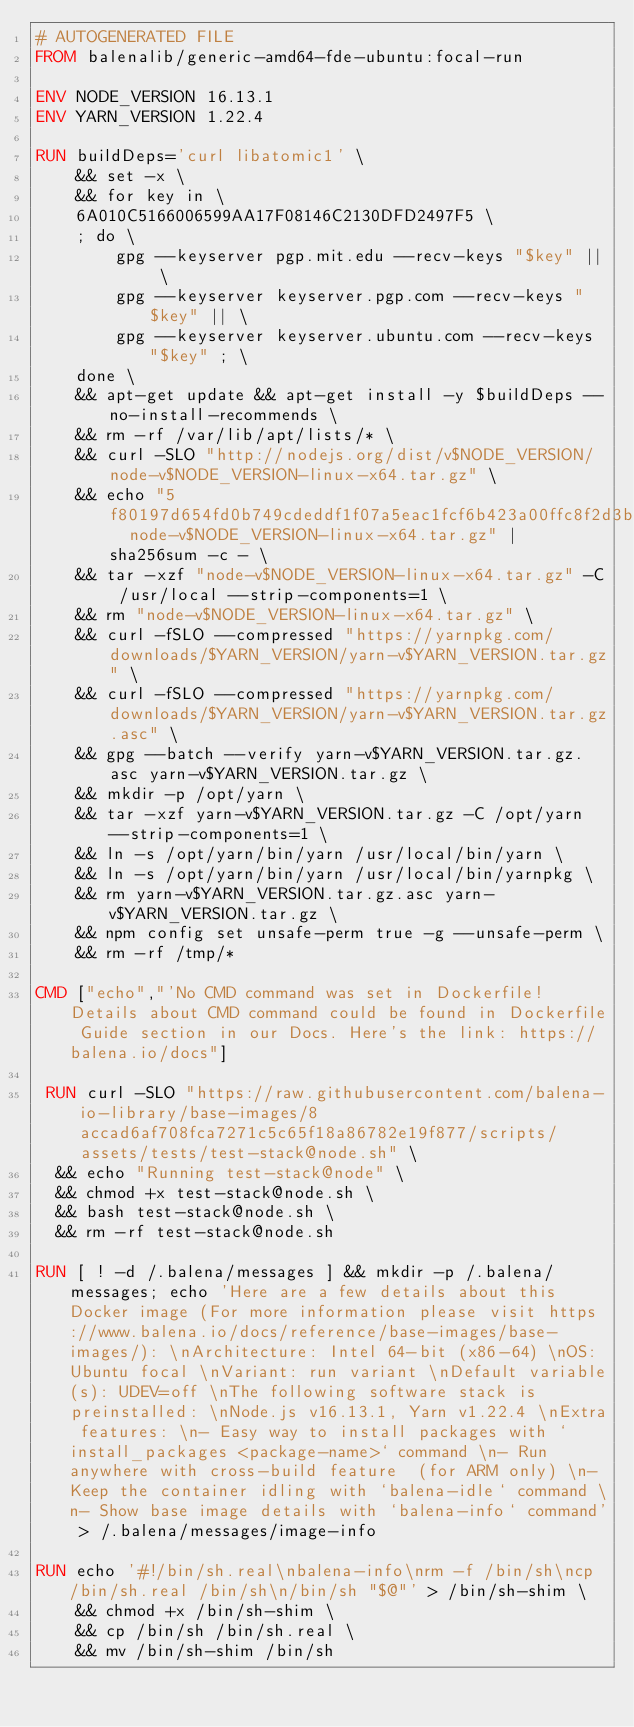<code> <loc_0><loc_0><loc_500><loc_500><_Dockerfile_># AUTOGENERATED FILE
FROM balenalib/generic-amd64-fde-ubuntu:focal-run

ENV NODE_VERSION 16.13.1
ENV YARN_VERSION 1.22.4

RUN buildDeps='curl libatomic1' \
	&& set -x \
	&& for key in \
	6A010C5166006599AA17F08146C2130DFD2497F5 \
	; do \
		gpg --keyserver pgp.mit.edu --recv-keys "$key" || \
		gpg --keyserver keyserver.pgp.com --recv-keys "$key" || \
		gpg --keyserver keyserver.ubuntu.com --recv-keys "$key" ; \
	done \
	&& apt-get update && apt-get install -y $buildDeps --no-install-recommends \
	&& rm -rf /var/lib/apt/lists/* \
	&& curl -SLO "http://nodejs.org/dist/v$NODE_VERSION/node-v$NODE_VERSION-linux-x64.tar.gz" \
	&& echo "5f80197d654fd0b749cdeddf1f07a5eac1fcf6b423a00ffc8f2d3bea9c6dc8d1  node-v$NODE_VERSION-linux-x64.tar.gz" | sha256sum -c - \
	&& tar -xzf "node-v$NODE_VERSION-linux-x64.tar.gz" -C /usr/local --strip-components=1 \
	&& rm "node-v$NODE_VERSION-linux-x64.tar.gz" \
	&& curl -fSLO --compressed "https://yarnpkg.com/downloads/$YARN_VERSION/yarn-v$YARN_VERSION.tar.gz" \
	&& curl -fSLO --compressed "https://yarnpkg.com/downloads/$YARN_VERSION/yarn-v$YARN_VERSION.tar.gz.asc" \
	&& gpg --batch --verify yarn-v$YARN_VERSION.tar.gz.asc yarn-v$YARN_VERSION.tar.gz \
	&& mkdir -p /opt/yarn \
	&& tar -xzf yarn-v$YARN_VERSION.tar.gz -C /opt/yarn --strip-components=1 \
	&& ln -s /opt/yarn/bin/yarn /usr/local/bin/yarn \
	&& ln -s /opt/yarn/bin/yarn /usr/local/bin/yarnpkg \
	&& rm yarn-v$YARN_VERSION.tar.gz.asc yarn-v$YARN_VERSION.tar.gz \
	&& npm config set unsafe-perm true -g --unsafe-perm \
	&& rm -rf /tmp/*

CMD ["echo","'No CMD command was set in Dockerfile! Details about CMD command could be found in Dockerfile Guide section in our Docs. Here's the link: https://balena.io/docs"]

 RUN curl -SLO "https://raw.githubusercontent.com/balena-io-library/base-images/8accad6af708fca7271c5c65f18a86782e19f877/scripts/assets/tests/test-stack@node.sh" \
  && echo "Running test-stack@node" \
  && chmod +x test-stack@node.sh \
  && bash test-stack@node.sh \
  && rm -rf test-stack@node.sh 

RUN [ ! -d /.balena/messages ] && mkdir -p /.balena/messages; echo 'Here are a few details about this Docker image (For more information please visit https://www.balena.io/docs/reference/base-images/base-images/): \nArchitecture: Intel 64-bit (x86-64) \nOS: Ubuntu focal \nVariant: run variant \nDefault variable(s): UDEV=off \nThe following software stack is preinstalled: \nNode.js v16.13.1, Yarn v1.22.4 \nExtra features: \n- Easy way to install packages with `install_packages <package-name>` command \n- Run anywhere with cross-build feature  (for ARM only) \n- Keep the container idling with `balena-idle` command \n- Show base image details with `balena-info` command' > /.balena/messages/image-info

RUN echo '#!/bin/sh.real\nbalena-info\nrm -f /bin/sh\ncp /bin/sh.real /bin/sh\n/bin/sh "$@"' > /bin/sh-shim \
	&& chmod +x /bin/sh-shim \
	&& cp /bin/sh /bin/sh.real \
	&& mv /bin/sh-shim /bin/sh</code> 